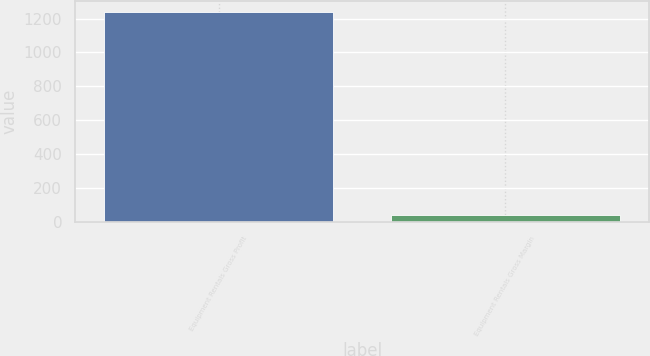Convert chart to OTSL. <chart><loc_0><loc_0><loc_500><loc_500><bar_chart><fcel>Equipment Rentals Gross Profit<fcel>Equipment Rentals Gross Margin<nl><fcel>1239<fcel>38.9<nl></chart> 